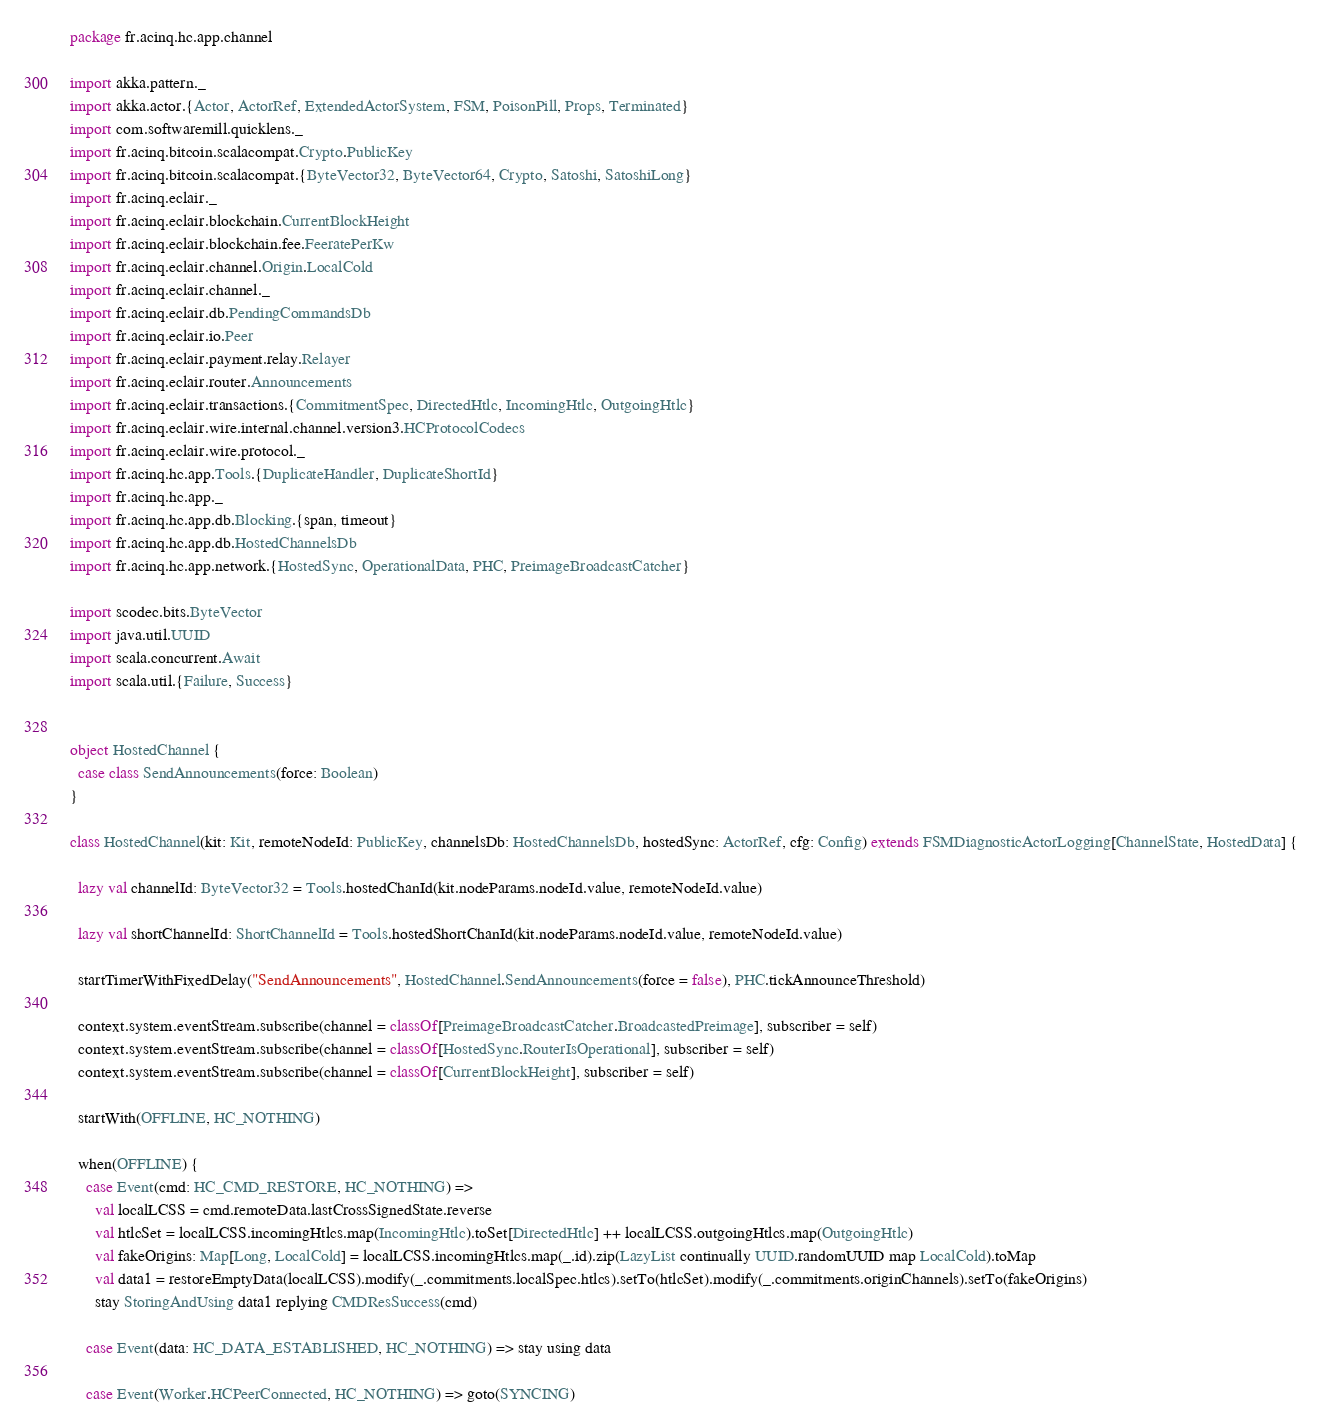Convert code to text. <code><loc_0><loc_0><loc_500><loc_500><_Scala_>package fr.acinq.hc.app.channel

import akka.pattern._
import akka.actor.{Actor, ActorRef, ExtendedActorSystem, FSM, PoisonPill, Props, Terminated}
import com.softwaremill.quicklens._
import fr.acinq.bitcoin.scalacompat.Crypto.PublicKey
import fr.acinq.bitcoin.scalacompat.{ByteVector32, ByteVector64, Crypto, Satoshi, SatoshiLong}
import fr.acinq.eclair._
import fr.acinq.eclair.blockchain.CurrentBlockHeight
import fr.acinq.eclair.blockchain.fee.FeeratePerKw
import fr.acinq.eclair.channel.Origin.LocalCold
import fr.acinq.eclair.channel._
import fr.acinq.eclair.db.PendingCommandsDb
import fr.acinq.eclair.io.Peer
import fr.acinq.eclair.payment.relay.Relayer
import fr.acinq.eclair.router.Announcements
import fr.acinq.eclair.transactions.{CommitmentSpec, DirectedHtlc, IncomingHtlc, OutgoingHtlc}
import fr.acinq.eclair.wire.internal.channel.version3.HCProtocolCodecs
import fr.acinq.eclair.wire.protocol._
import fr.acinq.hc.app.Tools.{DuplicateHandler, DuplicateShortId}
import fr.acinq.hc.app._
import fr.acinq.hc.app.db.Blocking.{span, timeout}
import fr.acinq.hc.app.db.HostedChannelsDb
import fr.acinq.hc.app.network.{HostedSync, OperationalData, PHC, PreimageBroadcastCatcher}

import scodec.bits.ByteVector
import java.util.UUID
import scala.concurrent.Await
import scala.util.{Failure, Success}


object HostedChannel {
  case class SendAnnouncements(force: Boolean)
}

class HostedChannel(kit: Kit, remoteNodeId: PublicKey, channelsDb: HostedChannelsDb, hostedSync: ActorRef, cfg: Config) extends FSMDiagnosticActorLogging[ChannelState, HostedData] {

  lazy val channelId: ByteVector32 = Tools.hostedChanId(kit.nodeParams.nodeId.value, remoteNodeId.value)

  lazy val shortChannelId: ShortChannelId = Tools.hostedShortChanId(kit.nodeParams.nodeId.value, remoteNodeId.value)

  startTimerWithFixedDelay("SendAnnouncements", HostedChannel.SendAnnouncements(force = false), PHC.tickAnnounceThreshold)

  context.system.eventStream.subscribe(channel = classOf[PreimageBroadcastCatcher.BroadcastedPreimage], subscriber = self)
  context.system.eventStream.subscribe(channel = classOf[HostedSync.RouterIsOperational], subscriber = self)
  context.system.eventStream.subscribe(channel = classOf[CurrentBlockHeight], subscriber = self)

  startWith(OFFLINE, HC_NOTHING)

  when(OFFLINE) {
    case Event(cmd: HC_CMD_RESTORE, HC_NOTHING) =>
      val localLCSS = cmd.remoteData.lastCrossSignedState.reverse
      val htlcSet = localLCSS.incomingHtlcs.map(IncomingHtlc).toSet[DirectedHtlc] ++ localLCSS.outgoingHtlcs.map(OutgoingHtlc)
      val fakeOrigins: Map[Long, LocalCold] = localLCSS.incomingHtlcs.map(_.id).zip(LazyList continually UUID.randomUUID map LocalCold).toMap
      val data1 = restoreEmptyData(localLCSS).modify(_.commitments.localSpec.htlcs).setTo(htlcSet).modify(_.commitments.originChannels).setTo(fakeOrigins)
      stay StoringAndUsing data1 replying CMDResSuccess(cmd)

    case Event(data: HC_DATA_ESTABLISHED, HC_NOTHING) => stay using data

    case Event(Worker.HCPeerConnected, HC_NOTHING) => goto(SYNCING)
</code> 